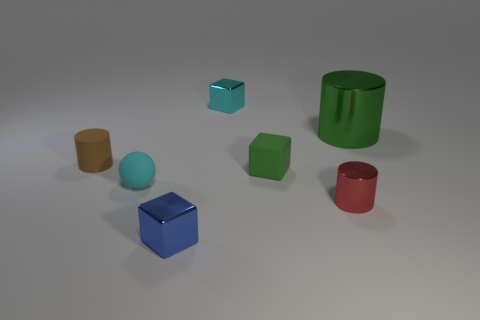Is there anything else that is the same size as the red object?
Keep it short and to the point. Yes. What number of cyan things are metallic spheres or balls?
Your answer should be compact. 1. How many green metallic things are the same size as the blue metal thing?
Ensure brevity in your answer.  0. There is a cylinder that is behind the small red shiny thing and on the right side of the tiny cyan ball; what color is it?
Ensure brevity in your answer.  Green. Are there more tiny cyan objects that are to the left of the small blue metal block than large green metal cylinders?
Keep it short and to the point. No. Is there a small blue block?
Offer a terse response. Yes. Is the big cylinder the same color as the rubber cylinder?
Give a very brief answer. No. What number of tiny things are blue matte blocks or balls?
Provide a short and direct response. 1. Is there any other thing of the same color as the large metallic cylinder?
Your answer should be compact. Yes. There is a red thing that is made of the same material as the tiny cyan block; what shape is it?
Keep it short and to the point. Cylinder. 